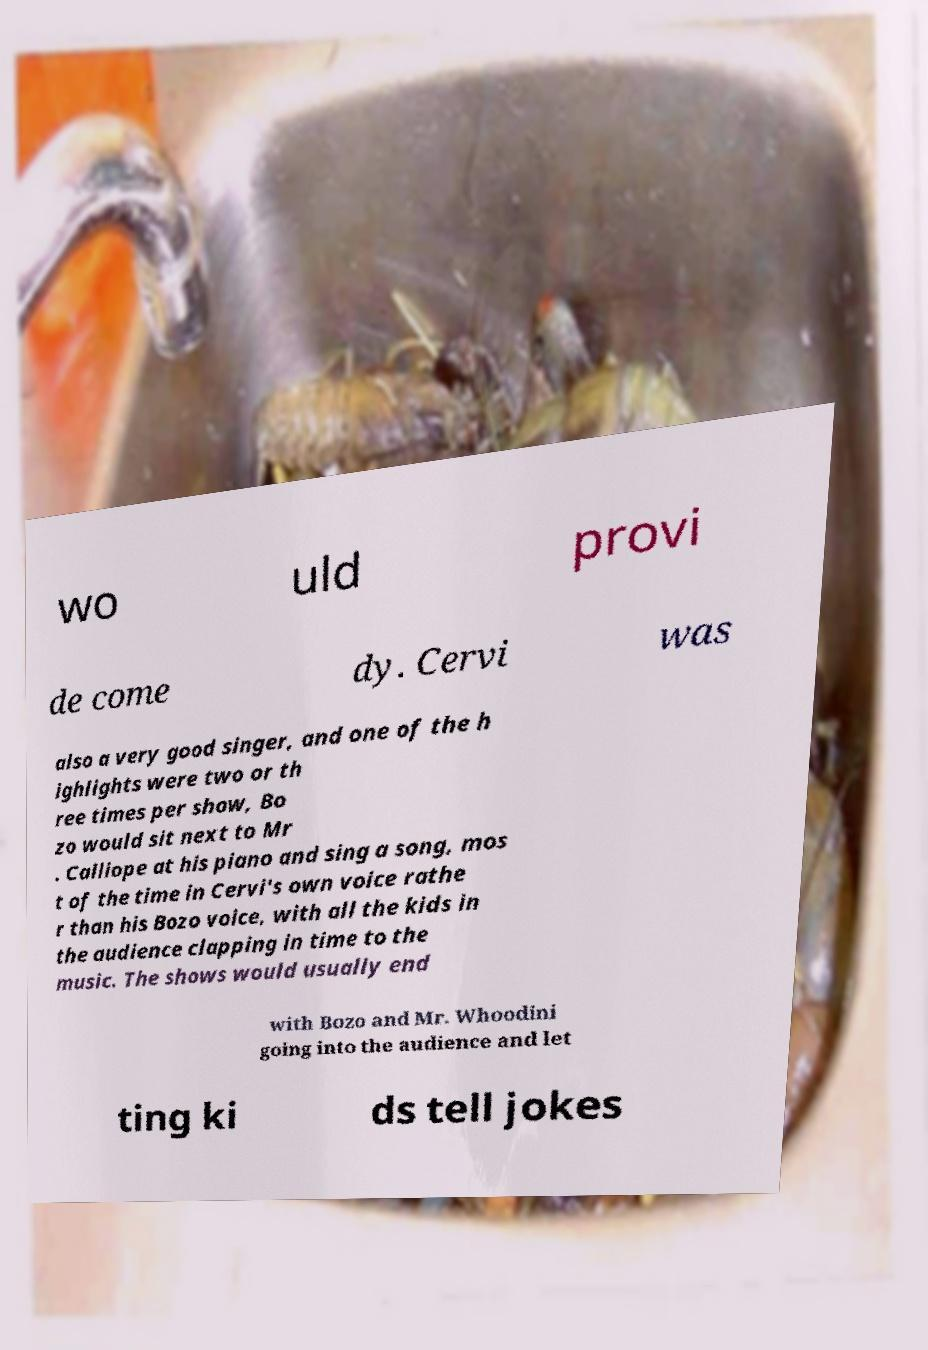What messages or text are displayed in this image? I need them in a readable, typed format. wo uld provi de come dy. Cervi was also a very good singer, and one of the h ighlights were two or th ree times per show, Bo zo would sit next to Mr . Calliope at his piano and sing a song, mos t of the time in Cervi's own voice rathe r than his Bozo voice, with all the kids in the audience clapping in time to the music. The shows would usually end with Bozo and Mr. Whoodini going into the audience and let ting ki ds tell jokes 